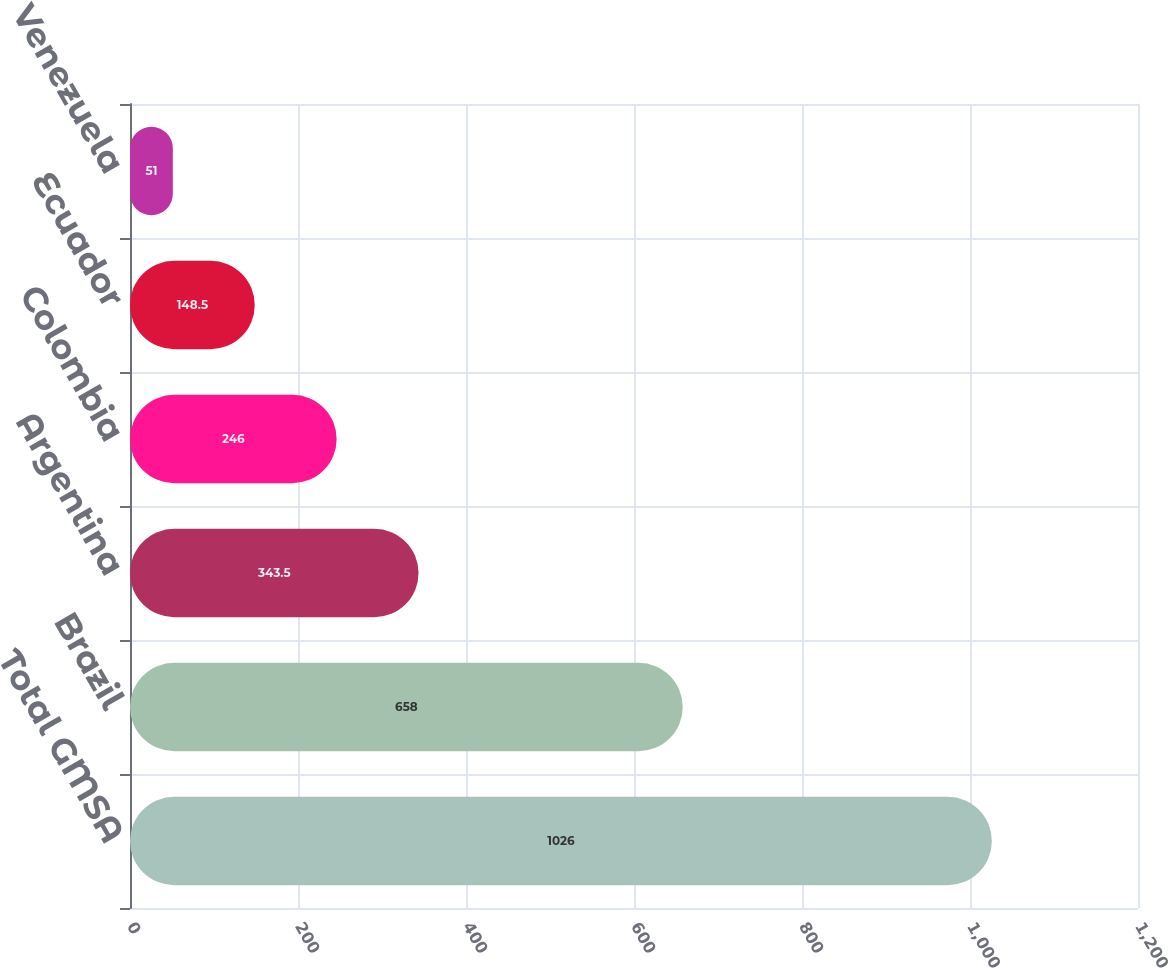Convert chart to OTSL. <chart><loc_0><loc_0><loc_500><loc_500><bar_chart><fcel>Total GMSA<fcel>Brazil<fcel>Argentina<fcel>Colombia<fcel>Ecuador<fcel>Venezuela<nl><fcel>1026<fcel>658<fcel>343.5<fcel>246<fcel>148.5<fcel>51<nl></chart> 